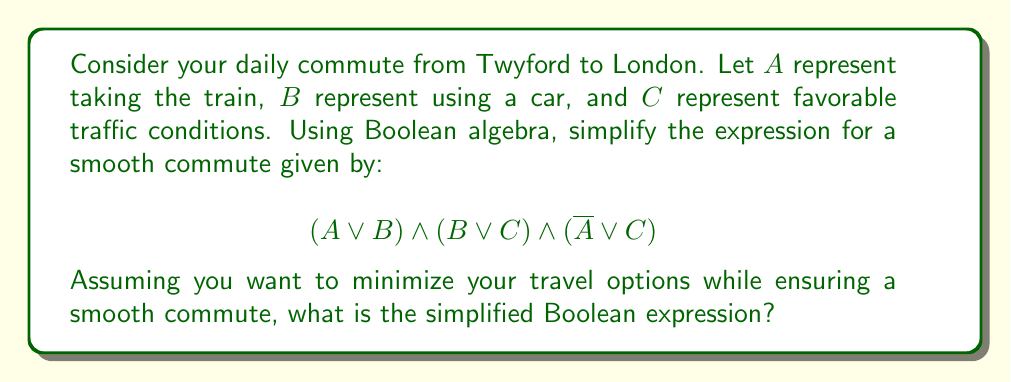Could you help me with this problem? Let's approach this step-by-step using Boolean algebra laws:

1) First, let's apply the distributive law to expand the expression:
   $$(A \lor B) \land (B \lor C) \land (\overline{A} \lor C)$$
   $= (AB \lor AC \lor BB \lor BC) \land (\overline{A} \lor C)$$

2) Simplify using the idempotent law ($BB = B$):
   $$(AB \lor AC \lor B \lor BC) \land (\overline{A} \lor C)$$

3) Apply the distributive law again:
   $$AB\overline{A} \lor AB C \lor AC\overline{A} \lor ACC \lor B\overline{A} \lor BC$$

4) Simplify using the complement law ($A\overline{A} = 0$) and idempotent law ($ACC = AC$):
   $$ABC \lor AC \lor B\overline{A} \lor BC$$

5) Use the absorption law ($AC \lor ABC = AC$):
   $$AC \lor B\overline{A} \lor BC$$

6) This expression cannot be simplified further using Boolean algebra laws.

The final expression $AC \lor B\overline{A} \lor BC$ represents the minimal conditions for a smooth commute:
- Take the train when traffic conditions are favorable (AC)
- Use the car when not taking the train (B\overline{A})
- Use the car when traffic conditions are favorable (BC)
Answer: $AC \lor B\overline{A} \lor BC$ 